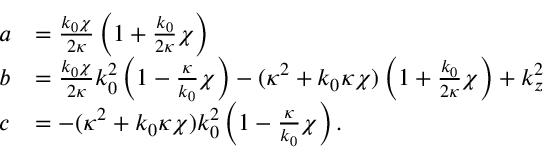Convert formula to latex. <formula><loc_0><loc_0><loc_500><loc_500>\begin{array} { c l } { a } & { = \frac { k _ { 0 } \chi } { 2 \kappa } \left ( 1 + \frac { k _ { 0 } } { 2 \kappa } \chi \right ) } \\ { b } & { = \frac { k _ { 0 } \chi } { 2 \kappa } k _ { 0 } ^ { 2 } \left ( 1 - \frac { \kappa } { k _ { 0 } } \chi \right ) - ( \kappa ^ { 2 } + k _ { 0 } \kappa \chi ) \left ( 1 + \frac { k _ { 0 } } { 2 \kappa } \chi \right ) + k _ { z } ^ { 2 } } \\ { c } & { = - ( \kappa ^ { 2 } + k _ { 0 } \kappa \chi ) k _ { 0 } ^ { 2 } \left ( 1 - \frac { \kappa } { k _ { 0 } } \chi \right ) . } \end{array}</formula> 